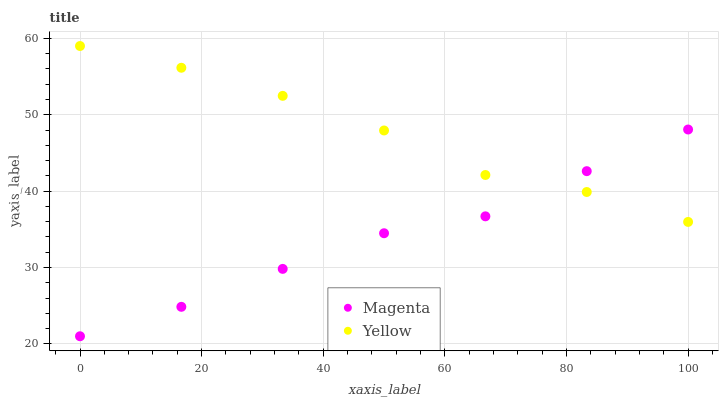Does Magenta have the minimum area under the curve?
Answer yes or no. Yes. Does Yellow have the maximum area under the curve?
Answer yes or no. Yes. Does Yellow have the minimum area under the curve?
Answer yes or no. No. Is Magenta the smoothest?
Answer yes or no. Yes. Is Yellow the roughest?
Answer yes or no. Yes. Is Yellow the smoothest?
Answer yes or no. No. Does Magenta have the lowest value?
Answer yes or no. Yes. Does Yellow have the lowest value?
Answer yes or no. No. Does Yellow have the highest value?
Answer yes or no. Yes. Does Magenta intersect Yellow?
Answer yes or no. Yes. Is Magenta less than Yellow?
Answer yes or no. No. Is Magenta greater than Yellow?
Answer yes or no. No. 